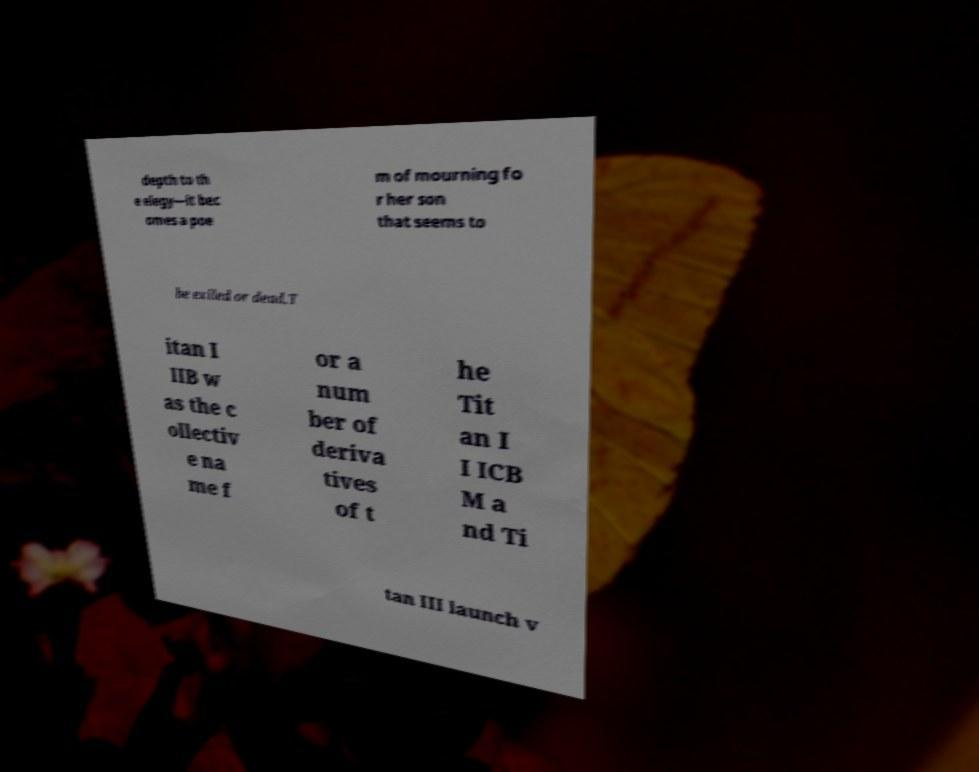Could you assist in decoding the text presented in this image and type it out clearly? depth to th e elegy—it bec omes a poe m of mourning fo r her son that seems to be exiled or dead.T itan I IIB w as the c ollectiv e na me f or a num ber of deriva tives of t he Tit an I I ICB M a nd Ti tan III launch v 